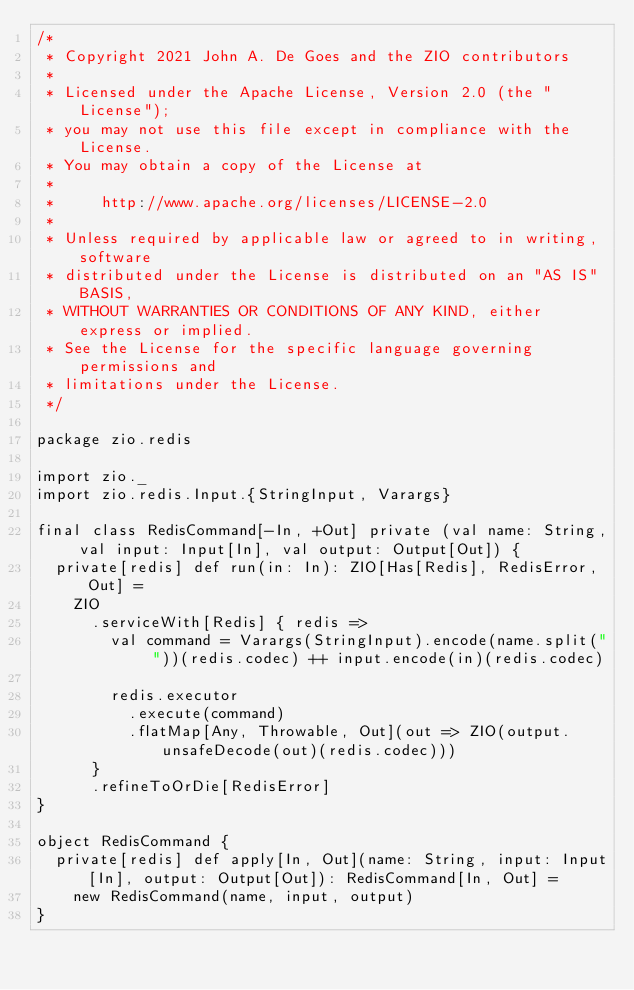Convert code to text. <code><loc_0><loc_0><loc_500><loc_500><_Scala_>/*
 * Copyright 2021 John A. De Goes and the ZIO contributors
 *
 * Licensed under the Apache License, Version 2.0 (the "License");
 * you may not use this file except in compliance with the License.
 * You may obtain a copy of the License at
 *
 *     http://www.apache.org/licenses/LICENSE-2.0
 *
 * Unless required by applicable law or agreed to in writing, software
 * distributed under the License is distributed on an "AS IS" BASIS,
 * WITHOUT WARRANTIES OR CONDITIONS OF ANY KIND, either express or implied.
 * See the License for the specific language governing permissions and
 * limitations under the License.
 */

package zio.redis

import zio._
import zio.redis.Input.{StringInput, Varargs}

final class RedisCommand[-In, +Out] private (val name: String, val input: Input[In], val output: Output[Out]) {
  private[redis] def run(in: In): ZIO[Has[Redis], RedisError, Out] =
    ZIO
      .serviceWith[Redis] { redis =>
        val command = Varargs(StringInput).encode(name.split(" "))(redis.codec) ++ input.encode(in)(redis.codec)

        redis.executor
          .execute(command)
          .flatMap[Any, Throwable, Out](out => ZIO(output.unsafeDecode(out)(redis.codec)))
      }
      .refineToOrDie[RedisError]
}

object RedisCommand {
  private[redis] def apply[In, Out](name: String, input: Input[In], output: Output[Out]): RedisCommand[In, Out] =
    new RedisCommand(name, input, output)
}
</code> 